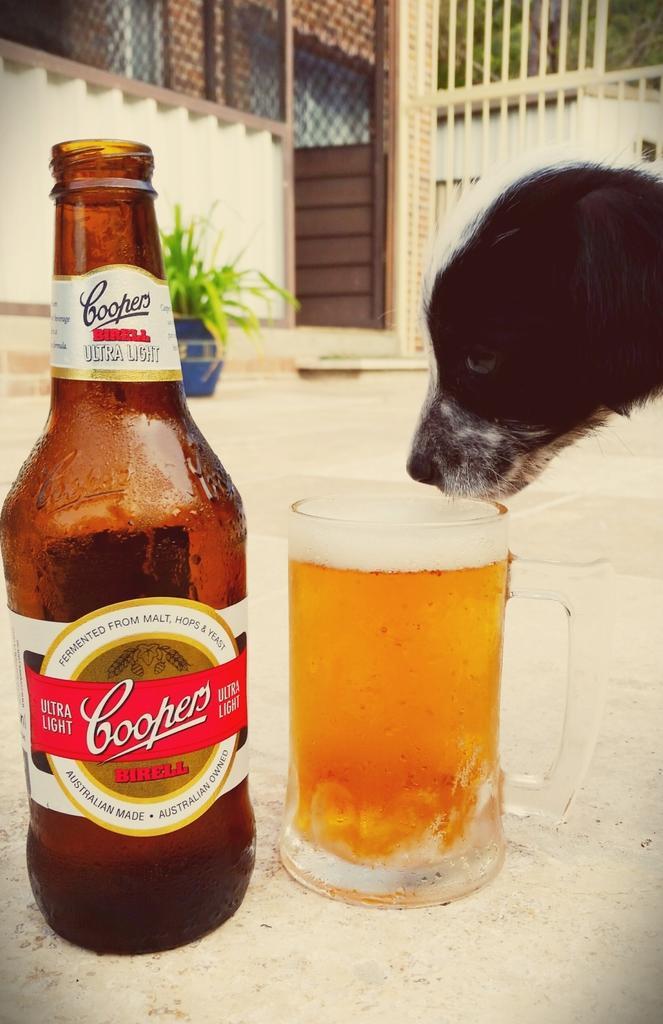Could you give a brief overview of what you see in this image? In this image there is a bottle and a glass which contains a wine and a dog looking in the glass and in the background there a wall in color and above that there is a black color fences and a door which is in black color. 